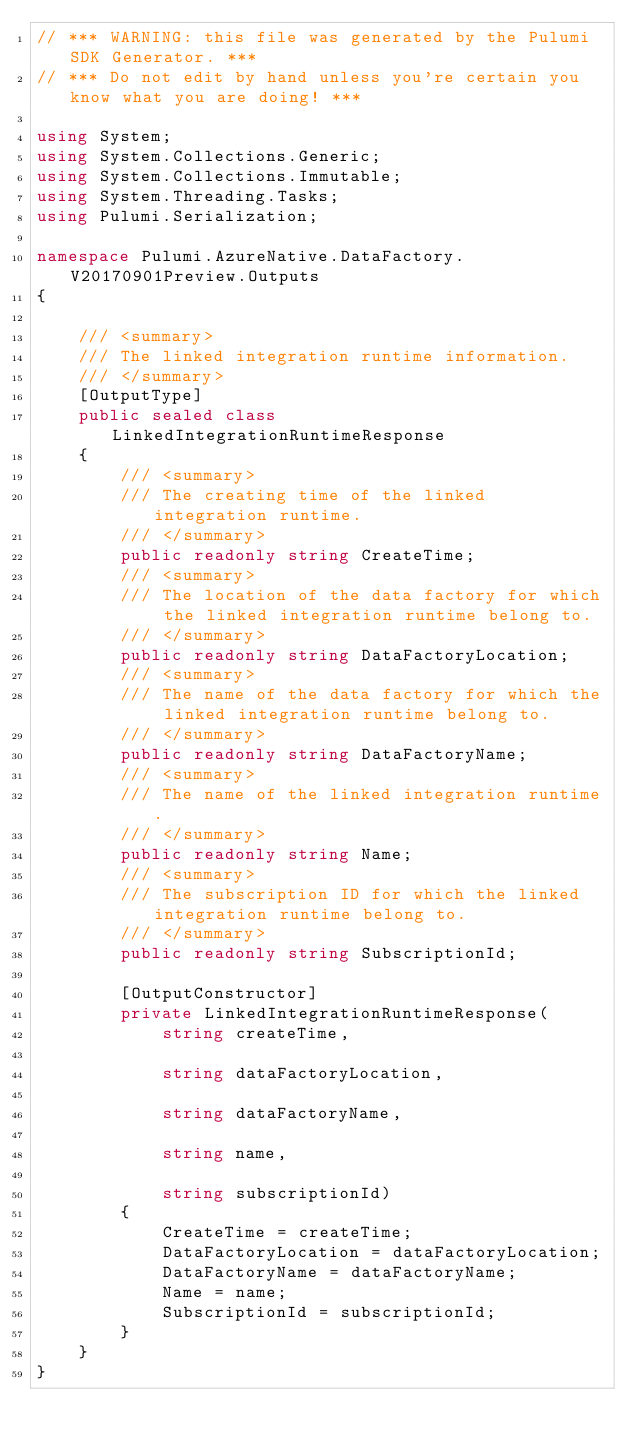<code> <loc_0><loc_0><loc_500><loc_500><_C#_>// *** WARNING: this file was generated by the Pulumi SDK Generator. ***
// *** Do not edit by hand unless you're certain you know what you are doing! ***

using System;
using System.Collections.Generic;
using System.Collections.Immutable;
using System.Threading.Tasks;
using Pulumi.Serialization;

namespace Pulumi.AzureNative.DataFactory.V20170901Preview.Outputs
{

    /// <summary>
    /// The linked integration runtime information.
    /// </summary>
    [OutputType]
    public sealed class LinkedIntegrationRuntimeResponse
    {
        /// <summary>
        /// The creating time of the linked integration runtime.
        /// </summary>
        public readonly string CreateTime;
        /// <summary>
        /// The location of the data factory for which the linked integration runtime belong to.
        /// </summary>
        public readonly string DataFactoryLocation;
        /// <summary>
        /// The name of the data factory for which the linked integration runtime belong to.
        /// </summary>
        public readonly string DataFactoryName;
        /// <summary>
        /// The name of the linked integration runtime.
        /// </summary>
        public readonly string Name;
        /// <summary>
        /// The subscription ID for which the linked integration runtime belong to.
        /// </summary>
        public readonly string SubscriptionId;

        [OutputConstructor]
        private LinkedIntegrationRuntimeResponse(
            string createTime,

            string dataFactoryLocation,

            string dataFactoryName,

            string name,

            string subscriptionId)
        {
            CreateTime = createTime;
            DataFactoryLocation = dataFactoryLocation;
            DataFactoryName = dataFactoryName;
            Name = name;
            SubscriptionId = subscriptionId;
        }
    }
}
</code> 